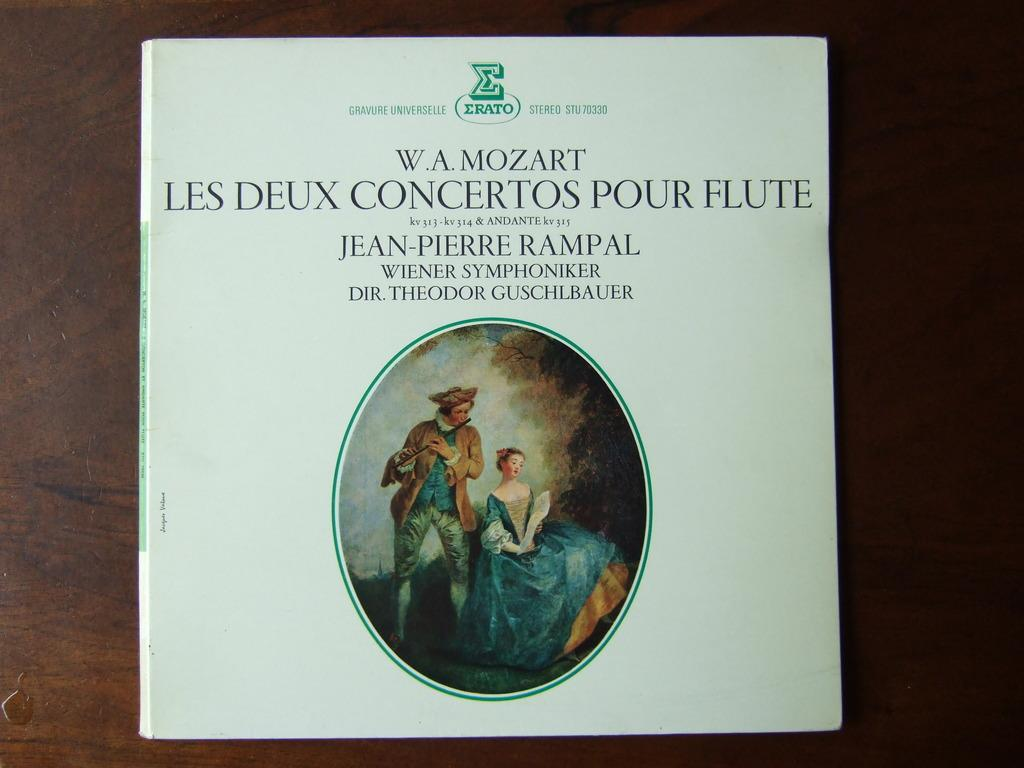<image>
Provide a brief description of the given image. Book about W.A. Mozart Les Deux concertos pour flute 